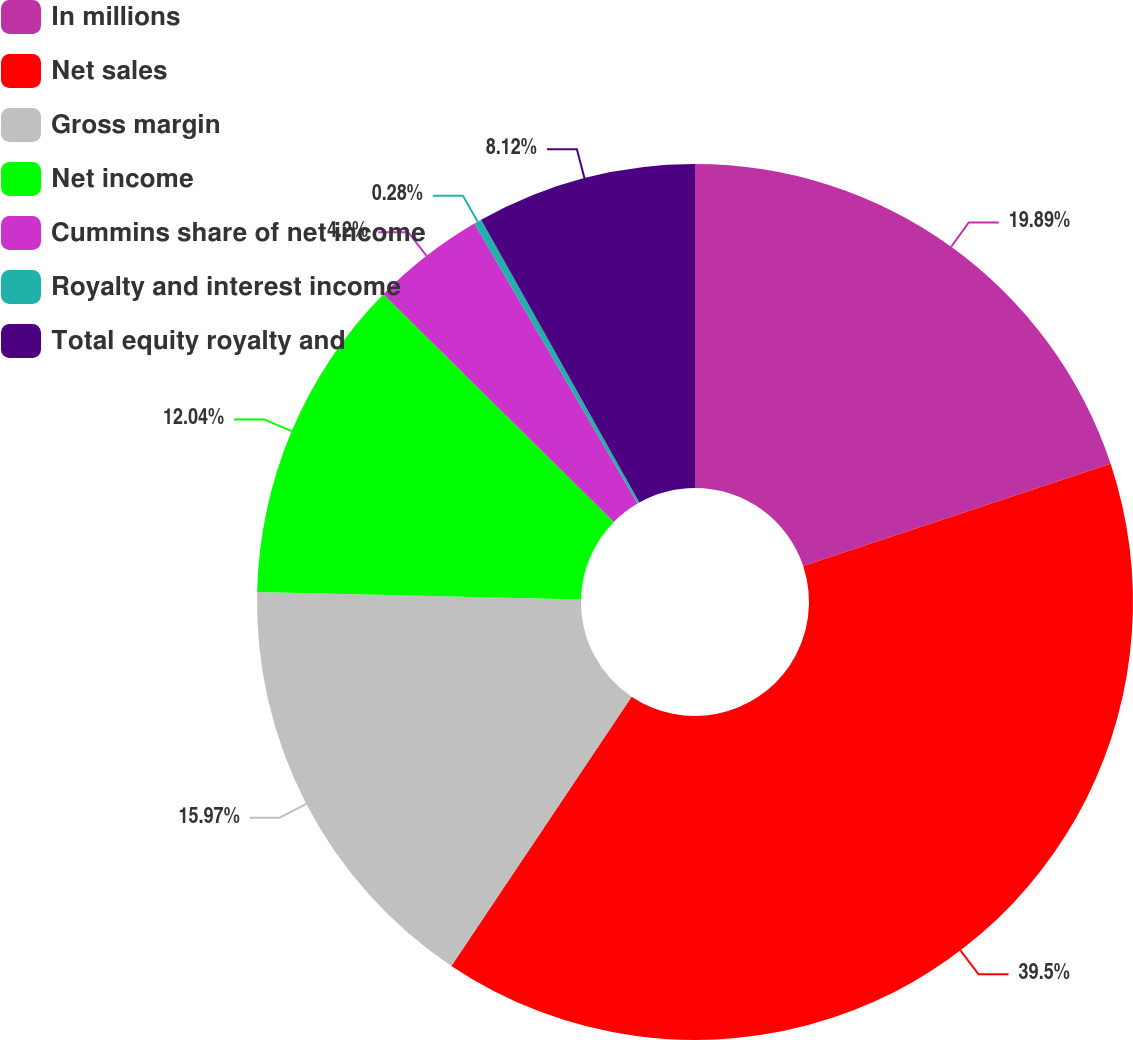Convert chart to OTSL. <chart><loc_0><loc_0><loc_500><loc_500><pie_chart><fcel>In millions<fcel>Net sales<fcel>Gross margin<fcel>Net income<fcel>Cummins share of net income<fcel>Royalty and interest income<fcel>Total equity royalty and<nl><fcel>19.89%<fcel>39.5%<fcel>15.97%<fcel>12.04%<fcel>4.2%<fcel>0.28%<fcel>8.12%<nl></chart> 